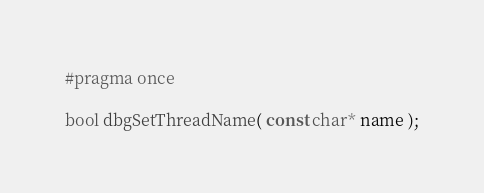Convert code to text. <code><loc_0><loc_0><loc_500><loc_500><_C_>#pragma once

bool dbgSetThreadName( const char* name );</code> 